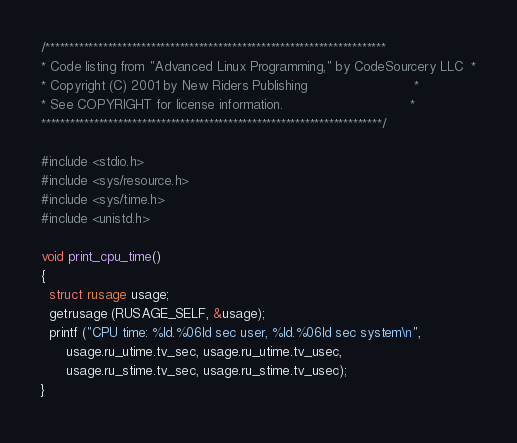Convert code to text. <code><loc_0><loc_0><loc_500><loc_500><_C_>/***********************************************************************
* Code listing from "Advanced Linux Programming," by CodeSourcery LLC  *
* Copyright (C) 2001 by New Riders Publishing                          *
* See COPYRIGHT for license information.                               *
***********************************************************************/

#include <stdio.h>
#include <sys/resource.h>
#include <sys/time.h>
#include <unistd.h>

void print_cpu_time()
{
  struct rusage usage;
  getrusage (RUSAGE_SELF, &usage);
  printf ("CPU time: %ld.%06ld sec user, %ld.%06ld sec system\n",
	  usage.ru_utime.tv_sec, usage.ru_utime.tv_usec,
	  usage.ru_stime.tv_sec, usage.ru_stime.tv_usec);
}
</code> 